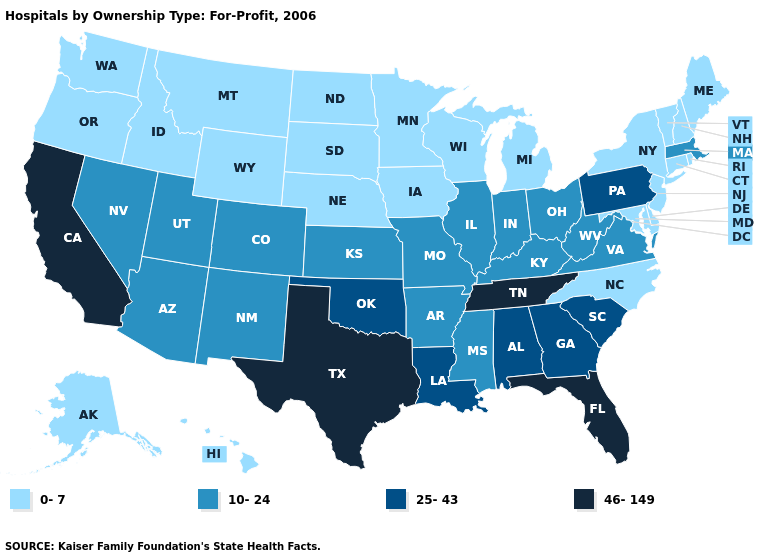What is the value of Texas?
Be succinct. 46-149. Name the states that have a value in the range 0-7?
Keep it brief. Alaska, Connecticut, Delaware, Hawaii, Idaho, Iowa, Maine, Maryland, Michigan, Minnesota, Montana, Nebraska, New Hampshire, New Jersey, New York, North Carolina, North Dakota, Oregon, Rhode Island, South Dakota, Vermont, Washington, Wisconsin, Wyoming. What is the value of Idaho?
Keep it brief. 0-7. Does the map have missing data?
Give a very brief answer. No. Which states have the highest value in the USA?
Concise answer only. California, Florida, Tennessee, Texas. Does Florida have the highest value in the USA?
Concise answer only. Yes. Does the first symbol in the legend represent the smallest category?
Be succinct. Yes. Does Louisiana have the same value as Maryland?
Answer briefly. No. What is the highest value in states that border Arizona?
Write a very short answer. 46-149. Which states have the lowest value in the South?
Concise answer only. Delaware, Maryland, North Carolina. Name the states that have a value in the range 0-7?
Quick response, please. Alaska, Connecticut, Delaware, Hawaii, Idaho, Iowa, Maine, Maryland, Michigan, Minnesota, Montana, Nebraska, New Hampshire, New Jersey, New York, North Carolina, North Dakota, Oregon, Rhode Island, South Dakota, Vermont, Washington, Wisconsin, Wyoming. Among the states that border North Carolina , which have the highest value?
Be succinct. Tennessee. Which states have the lowest value in the USA?
Be succinct. Alaska, Connecticut, Delaware, Hawaii, Idaho, Iowa, Maine, Maryland, Michigan, Minnesota, Montana, Nebraska, New Hampshire, New Jersey, New York, North Carolina, North Dakota, Oregon, Rhode Island, South Dakota, Vermont, Washington, Wisconsin, Wyoming. Name the states that have a value in the range 10-24?
Concise answer only. Arizona, Arkansas, Colorado, Illinois, Indiana, Kansas, Kentucky, Massachusetts, Mississippi, Missouri, Nevada, New Mexico, Ohio, Utah, Virginia, West Virginia. Name the states that have a value in the range 10-24?
Answer briefly. Arizona, Arkansas, Colorado, Illinois, Indiana, Kansas, Kentucky, Massachusetts, Mississippi, Missouri, Nevada, New Mexico, Ohio, Utah, Virginia, West Virginia. 